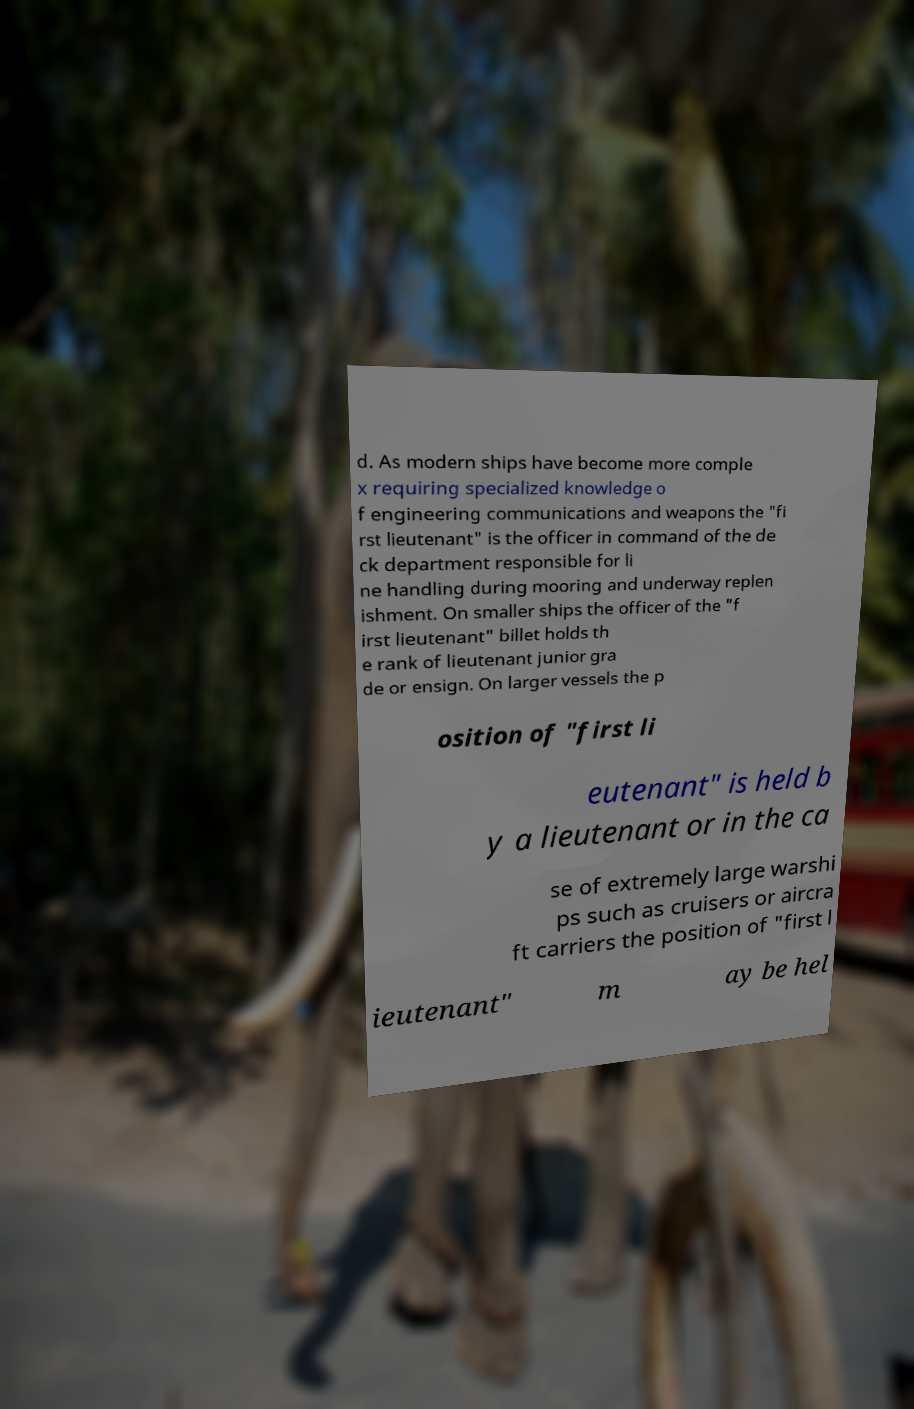Could you extract and type out the text from this image? d. As modern ships have become more comple x requiring specialized knowledge o f engineering communications and weapons the "fi rst lieutenant" is the officer in command of the de ck department responsible for li ne handling during mooring and underway replen ishment. On smaller ships the officer of the "f irst lieutenant" billet holds th e rank of lieutenant junior gra de or ensign. On larger vessels the p osition of "first li eutenant" is held b y a lieutenant or in the ca se of extremely large warshi ps such as cruisers or aircra ft carriers the position of "first l ieutenant" m ay be hel 